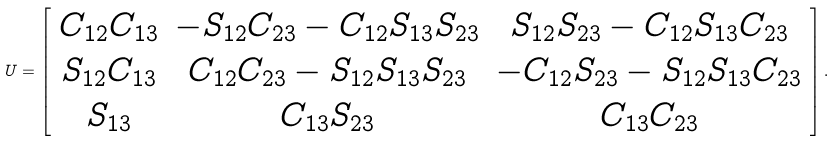Convert formula to latex. <formula><loc_0><loc_0><loc_500><loc_500>U = \left [ \begin{array} { c c c } C _ { 1 2 } C _ { 1 3 } & - S _ { 1 2 } C _ { 2 3 } - C _ { 1 2 } S _ { 1 3 } S _ { 2 3 } & S _ { 1 2 } S _ { 2 3 } - C _ { 1 2 } S _ { 1 3 } C _ { 2 3 } \\ S _ { 1 2 } C _ { 1 3 } & C _ { 1 2 } C _ { 2 3 } - S _ { 1 2 } S _ { 1 3 } S _ { 2 3 } & - C _ { 1 2 } S _ { 2 3 } - S _ { 1 2 } S _ { 1 3 } C _ { 2 3 } \\ S _ { 1 3 } & C _ { 1 3 } S _ { 2 3 } & C _ { 1 3 } C _ { 2 3 } \end{array} \right ] .</formula> 